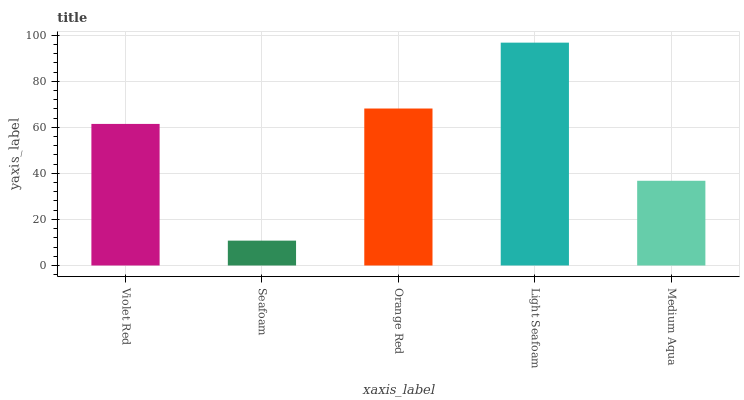Is Seafoam the minimum?
Answer yes or no. Yes. Is Light Seafoam the maximum?
Answer yes or no. Yes. Is Orange Red the minimum?
Answer yes or no. No. Is Orange Red the maximum?
Answer yes or no. No. Is Orange Red greater than Seafoam?
Answer yes or no. Yes. Is Seafoam less than Orange Red?
Answer yes or no. Yes. Is Seafoam greater than Orange Red?
Answer yes or no. No. Is Orange Red less than Seafoam?
Answer yes or no. No. Is Violet Red the high median?
Answer yes or no. Yes. Is Violet Red the low median?
Answer yes or no. Yes. Is Seafoam the high median?
Answer yes or no. No. Is Light Seafoam the low median?
Answer yes or no. No. 